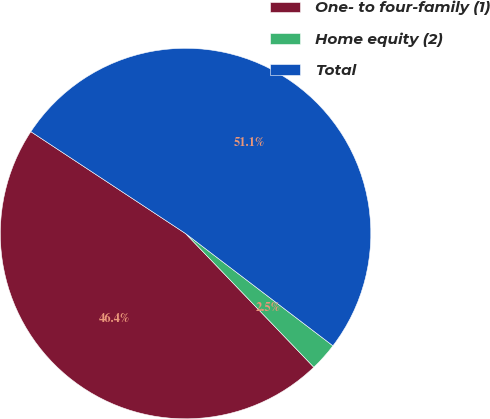Convert chart. <chart><loc_0><loc_0><loc_500><loc_500><pie_chart><fcel>One- to four-family (1)<fcel>Home equity (2)<fcel>Total<nl><fcel>46.44%<fcel>2.47%<fcel>51.09%<nl></chart> 